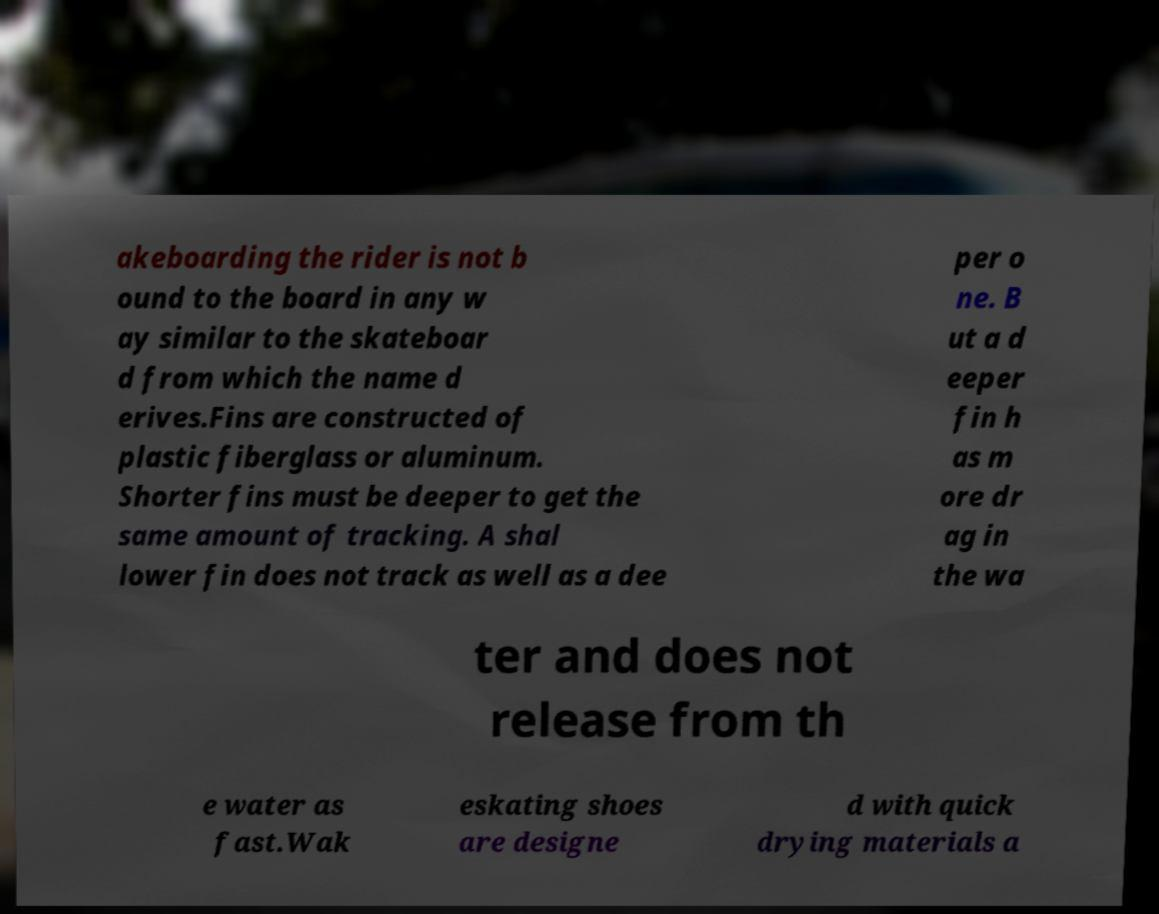Can you accurately transcribe the text from the provided image for me? akeboarding the rider is not b ound to the board in any w ay similar to the skateboar d from which the name d erives.Fins are constructed of plastic fiberglass or aluminum. Shorter fins must be deeper to get the same amount of tracking. A shal lower fin does not track as well as a dee per o ne. B ut a d eeper fin h as m ore dr ag in the wa ter and does not release from th e water as fast.Wak eskating shoes are designe d with quick drying materials a 